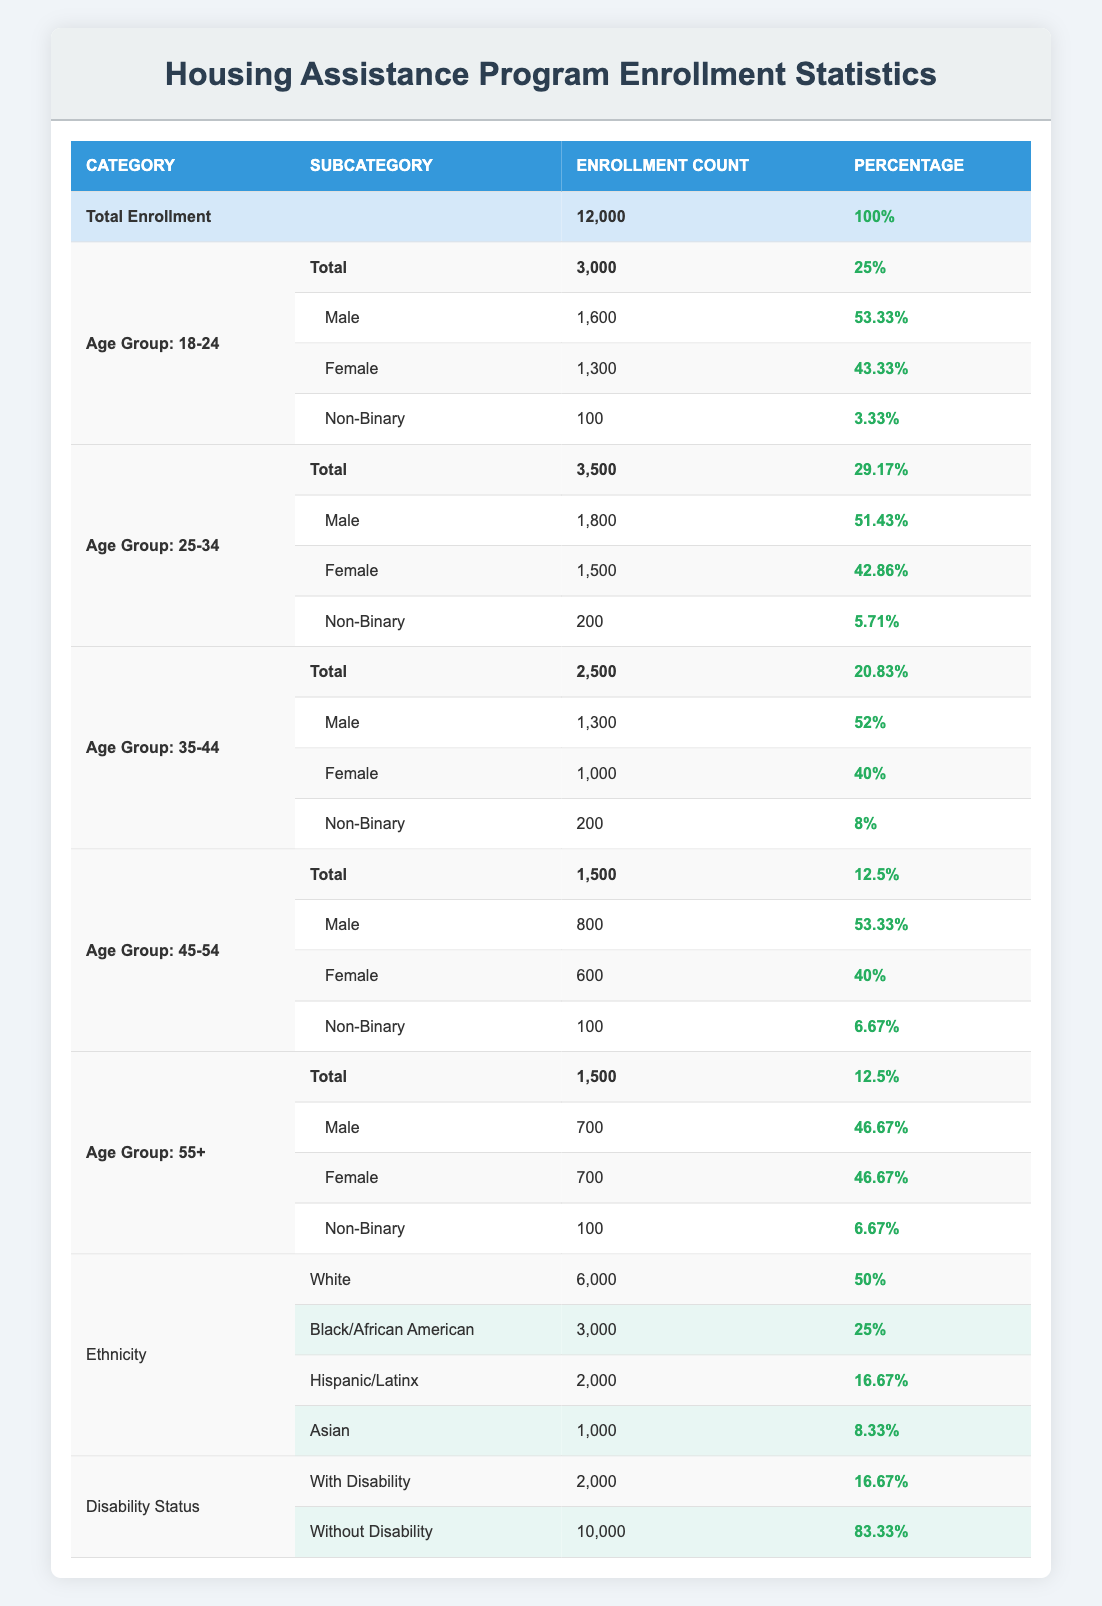What is the total enrollment in the Housing Assistance Program? The total enrollment is clearly stated in the table under the "Total Enrollment" row, which shows a count of 12,000.
Answer: 12000 How many individuals aged 25-34 are enrolled in the program? The enrollment count for the age group 25-34 is indicated in the corresponding row labeled "Age Group: 25-34," which shows an enrollment count of 3,500.
Answer: 3500 What percentage of participants are Black/African American? The percentage of Black/African American participants is provided in the ethnicity section of the table, specifically under the row for "Black/African American," which shows a percentage of 25%.
Answer: 25% How many more male participants are there in the age group 18-24 compared to the age group 45-54? First, identify the enrollment count of male participants in each age group: 18-24 has 1,600 and 45-54 has 800. The difference is calculated as 1,600 - 800 = 800, this means there are 800 more male participants in the 18-24 age group.
Answer: 800 Is the percentage of enrolled individuals with a disability higher than those without a disability? In the disability section, the percentage for those with a disability is 16.67%, and for those without, it is 83.33%. Since 16.67% is less than 83.33%, the answer is no.
Answer: No What is the combined enrollment of participants aged 35-44 and 55+? To find this, you need the enrollment counts for both age groups: 35-44 has 2,500 and 55+ has 1,500. The sum is 2,500 + 1,500 = 4,000.
Answer: 4000 What percentage of total enrollment does the Hispanic/Latinx group represent? The table indicates that the Hispanic/Latinx group has an enrollment count of 2,000, and the total enrollment is 12,000. The percentage is calculated as (2,000 / 12,000) * 100 = 16.67%.
Answer: 16.67% How many female participants are there in the age group 35-44? The enrollment count for female participants in the age group 35-44 is noted in the table, specifically showing a count of 1,000.
Answer: 1000 Which age group has the highest percentage of enrollment? By examining the table, the age group with the highest enrollment percentage is 25-34, showcasing 29.17%, higher than any other age group listed.
Answer: 25-34 